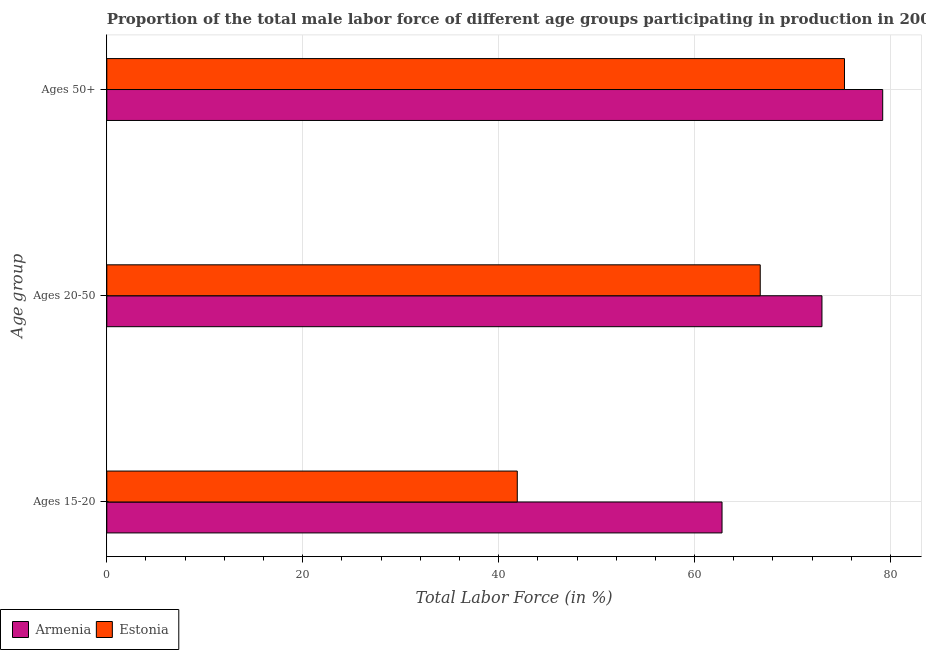How many groups of bars are there?
Your answer should be very brief. 3. Are the number of bars per tick equal to the number of legend labels?
Provide a succinct answer. Yes. Are the number of bars on each tick of the Y-axis equal?
Offer a very short reply. Yes. How many bars are there on the 2nd tick from the top?
Offer a terse response. 2. What is the label of the 1st group of bars from the top?
Give a very brief answer. Ages 50+. What is the percentage of male labor force within the age group 15-20 in Estonia?
Make the answer very short. 41.9. Across all countries, what is the maximum percentage of male labor force within the age group 20-50?
Ensure brevity in your answer.  73. Across all countries, what is the minimum percentage of male labor force within the age group 20-50?
Ensure brevity in your answer.  66.7. In which country was the percentage of male labor force within the age group 15-20 maximum?
Ensure brevity in your answer.  Armenia. In which country was the percentage of male labor force within the age group 20-50 minimum?
Your answer should be very brief. Estonia. What is the total percentage of male labor force above age 50 in the graph?
Provide a short and direct response. 154.5. What is the difference between the percentage of male labor force within the age group 15-20 in Estonia and that in Armenia?
Your answer should be compact. -20.9. What is the difference between the percentage of male labor force within the age group 20-50 in Armenia and the percentage of male labor force within the age group 15-20 in Estonia?
Your response must be concise. 31.1. What is the average percentage of male labor force within the age group 15-20 per country?
Provide a succinct answer. 52.35. What is the difference between the percentage of male labor force within the age group 15-20 and percentage of male labor force within the age group 20-50 in Estonia?
Ensure brevity in your answer.  -24.8. In how many countries, is the percentage of male labor force above age 50 greater than 60 %?
Provide a succinct answer. 2. What is the ratio of the percentage of male labor force within the age group 15-20 in Estonia to that in Armenia?
Give a very brief answer. 0.67. What is the difference between the highest and the second highest percentage of male labor force above age 50?
Give a very brief answer. 3.9. What is the difference between the highest and the lowest percentage of male labor force within the age group 20-50?
Your response must be concise. 6.3. In how many countries, is the percentage of male labor force within the age group 15-20 greater than the average percentage of male labor force within the age group 15-20 taken over all countries?
Offer a terse response. 1. What does the 2nd bar from the top in Ages 20-50 represents?
Provide a succinct answer. Armenia. What does the 2nd bar from the bottom in Ages 15-20 represents?
Keep it short and to the point. Estonia. Is it the case that in every country, the sum of the percentage of male labor force within the age group 15-20 and percentage of male labor force within the age group 20-50 is greater than the percentage of male labor force above age 50?
Keep it short and to the point. Yes. Are all the bars in the graph horizontal?
Provide a succinct answer. Yes. What is the difference between two consecutive major ticks on the X-axis?
Provide a short and direct response. 20. Are the values on the major ticks of X-axis written in scientific E-notation?
Give a very brief answer. No. Where does the legend appear in the graph?
Ensure brevity in your answer.  Bottom left. What is the title of the graph?
Offer a terse response. Proportion of the total male labor force of different age groups participating in production in 2000. What is the label or title of the Y-axis?
Keep it short and to the point. Age group. What is the Total Labor Force (in %) in Armenia in Ages 15-20?
Provide a succinct answer. 62.8. What is the Total Labor Force (in %) of Estonia in Ages 15-20?
Provide a succinct answer. 41.9. What is the Total Labor Force (in %) in Armenia in Ages 20-50?
Your response must be concise. 73. What is the Total Labor Force (in %) in Estonia in Ages 20-50?
Ensure brevity in your answer.  66.7. What is the Total Labor Force (in %) in Armenia in Ages 50+?
Your response must be concise. 79.2. What is the Total Labor Force (in %) of Estonia in Ages 50+?
Provide a short and direct response. 75.3. Across all Age group, what is the maximum Total Labor Force (in %) of Armenia?
Keep it short and to the point. 79.2. Across all Age group, what is the maximum Total Labor Force (in %) of Estonia?
Give a very brief answer. 75.3. Across all Age group, what is the minimum Total Labor Force (in %) in Armenia?
Ensure brevity in your answer.  62.8. Across all Age group, what is the minimum Total Labor Force (in %) of Estonia?
Ensure brevity in your answer.  41.9. What is the total Total Labor Force (in %) in Armenia in the graph?
Your answer should be compact. 215. What is the total Total Labor Force (in %) in Estonia in the graph?
Give a very brief answer. 183.9. What is the difference between the Total Labor Force (in %) of Armenia in Ages 15-20 and that in Ages 20-50?
Ensure brevity in your answer.  -10.2. What is the difference between the Total Labor Force (in %) in Estonia in Ages 15-20 and that in Ages 20-50?
Offer a terse response. -24.8. What is the difference between the Total Labor Force (in %) of Armenia in Ages 15-20 and that in Ages 50+?
Your response must be concise. -16.4. What is the difference between the Total Labor Force (in %) of Estonia in Ages 15-20 and that in Ages 50+?
Your response must be concise. -33.4. What is the difference between the Total Labor Force (in %) of Armenia in Ages 15-20 and the Total Labor Force (in %) of Estonia in Ages 20-50?
Keep it short and to the point. -3.9. What is the difference between the Total Labor Force (in %) in Armenia in Ages 15-20 and the Total Labor Force (in %) in Estonia in Ages 50+?
Your answer should be very brief. -12.5. What is the difference between the Total Labor Force (in %) of Armenia in Ages 20-50 and the Total Labor Force (in %) of Estonia in Ages 50+?
Offer a terse response. -2.3. What is the average Total Labor Force (in %) in Armenia per Age group?
Ensure brevity in your answer.  71.67. What is the average Total Labor Force (in %) of Estonia per Age group?
Make the answer very short. 61.3. What is the difference between the Total Labor Force (in %) of Armenia and Total Labor Force (in %) of Estonia in Ages 15-20?
Give a very brief answer. 20.9. What is the difference between the Total Labor Force (in %) of Armenia and Total Labor Force (in %) of Estonia in Ages 20-50?
Provide a short and direct response. 6.3. What is the difference between the Total Labor Force (in %) in Armenia and Total Labor Force (in %) in Estonia in Ages 50+?
Keep it short and to the point. 3.9. What is the ratio of the Total Labor Force (in %) of Armenia in Ages 15-20 to that in Ages 20-50?
Ensure brevity in your answer.  0.86. What is the ratio of the Total Labor Force (in %) in Estonia in Ages 15-20 to that in Ages 20-50?
Your answer should be compact. 0.63. What is the ratio of the Total Labor Force (in %) of Armenia in Ages 15-20 to that in Ages 50+?
Offer a very short reply. 0.79. What is the ratio of the Total Labor Force (in %) in Estonia in Ages 15-20 to that in Ages 50+?
Make the answer very short. 0.56. What is the ratio of the Total Labor Force (in %) of Armenia in Ages 20-50 to that in Ages 50+?
Provide a short and direct response. 0.92. What is the ratio of the Total Labor Force (in %) of Estonia in Ages 20-50 to that in Ages 50+?
Provide a short and direct response. 0.89. What is the difference between the highest and the second highest Total Labor Force (in %) of Armenia?
Your answer should be very brief. 6.2. What is the difference between the highest and the lowest Total Labor Force (in %) of Estonia?
Give a very brief answer. 33.4. 